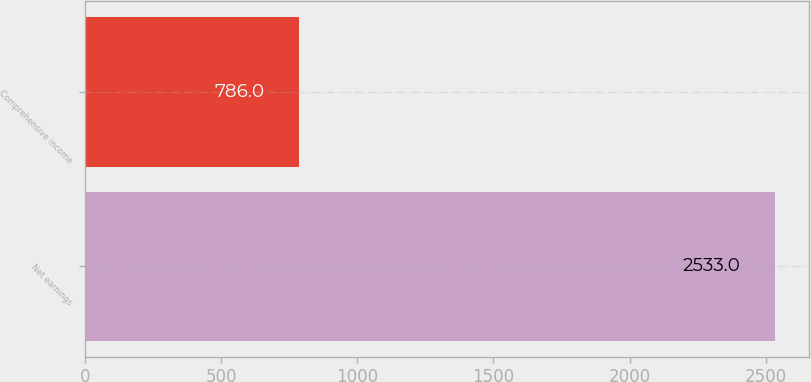Convert chart. <chart><loc_0><loc_0><loc_500><loc_500><bar_chart><fcel>Net earnings<fcel>Comprehensive income<nl><fcel>2533<fcel>786<nl></chart> 